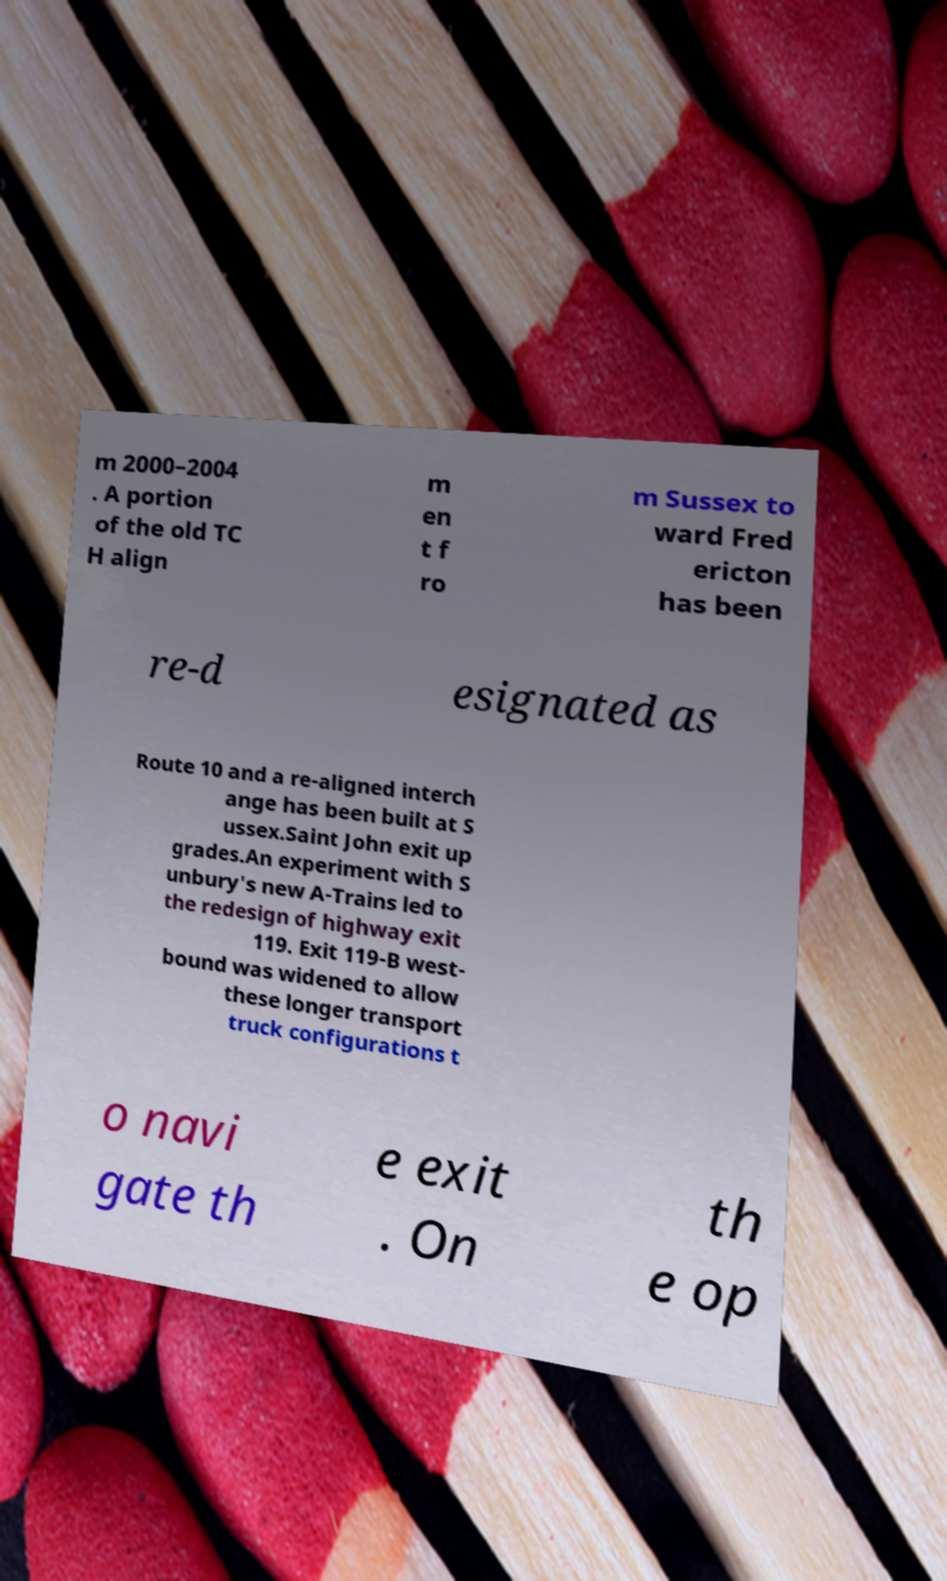Please read and relay the text visible in this image. What does it say? m 2000–2004 . A portion of the old TC H align m en t f ro m Sussex to ward Fred ericton has been re-d esignated as Route 10 and a re-aligned interch ange has been built at S ussex.Saint John exit up grades.An experiment with S unbury's new A-Trains led to the redesign of highway exit 119. Exit 119-B west- bound was widened to allow these longer transport truck configurations t o navi gate th e exit . On th e op 